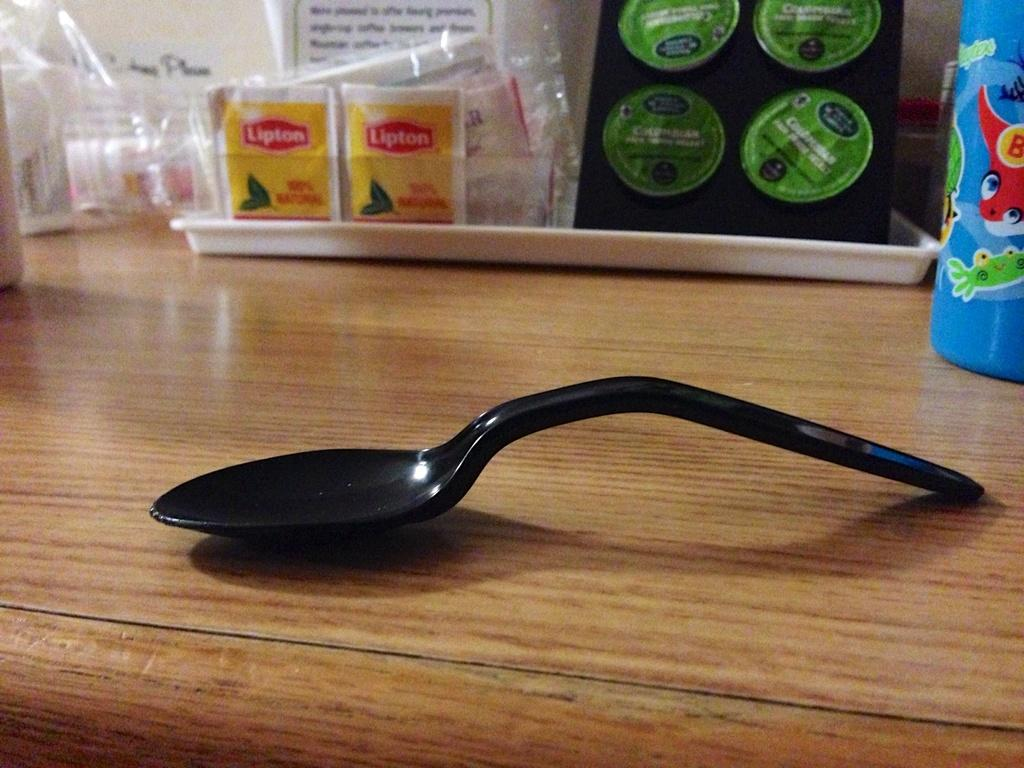What type of table is in the image? There is a wooden table in the image. What color is the spoon on the table? The spoon on the table is black in color. What is on the table besides the spoon? There is a white tray and a blue color water bottle on the table. What items are on the tray? There are tea bags on the tray, and it has a black color cover. What is the title of the book that is being read at the table? There is no book or reading activity depicted in the image. 